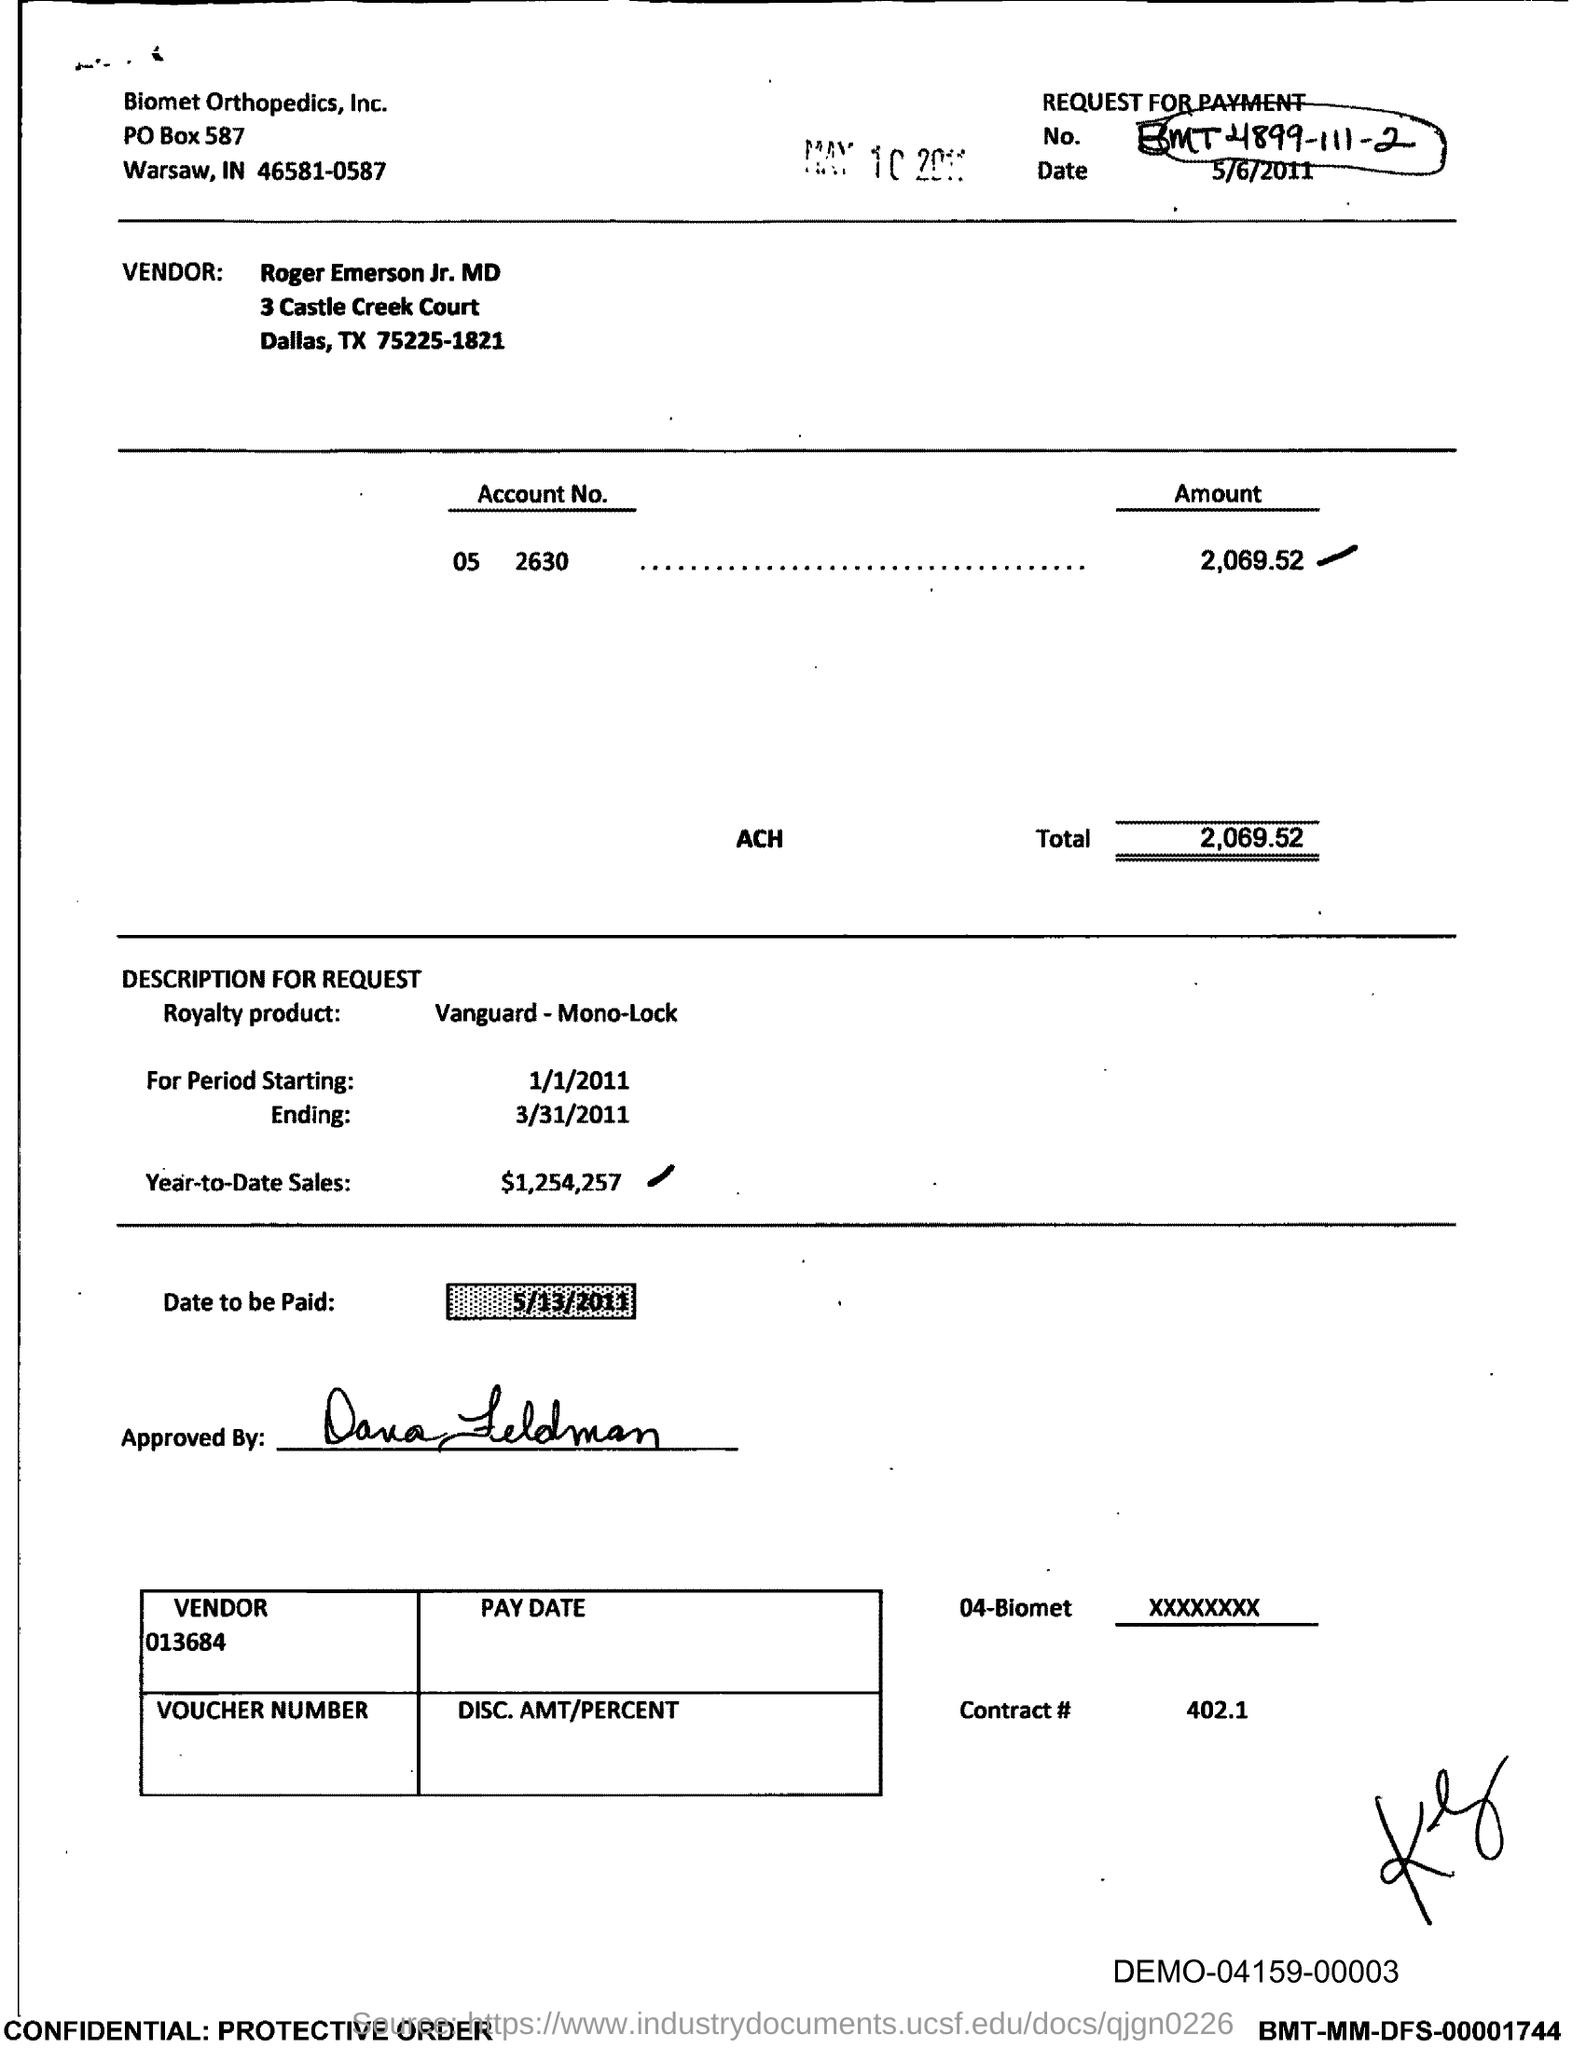Which company is mentioned in the header of the document?
Provide a succinct answer. Biomet Orthopedics, Inc. What is the request for payment No. given in the document?
Ensure brevity in your answer.  BMT4899-111-2. Who is the Vendor mentioned in the document?
Ensure brevity in your answer.  Roger Emerson Jr. MD. What is the Account No. given in the document?
Provide a succinct answer. 05 2630. What is the total amount to be paid?
Offer a terse response. 2,069.52. What is the Year-to-Date Sales of the royalty product?
Your response must be concise. $1,254,257. What is the contract# given in the document?
Your answer should be compact. 402.1. What is the date to be paid mentioned in the document?
Give a very brief answer. 5/13/2011. 